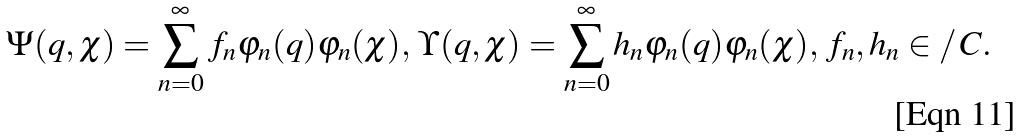Convert formula to latex. <formula><loc_0><loc_0><loc_500><loc_500>\Psi ( q , \chi ) = \sum _ { n = 0 } ^ { \infty } f _ { n } \varphi _ { n } ( q ) \varphi _ { n } ( \chi ) , \, \Upsilon ( q , \chi ) = \sum _ { n = 0 } ^ { \infty } h _ { n } \varphi _ { n } ( q ) \varphi _ { n } ( \chi ) , \, f _ { n } , h _ { n } \in / \, C .</formula> 